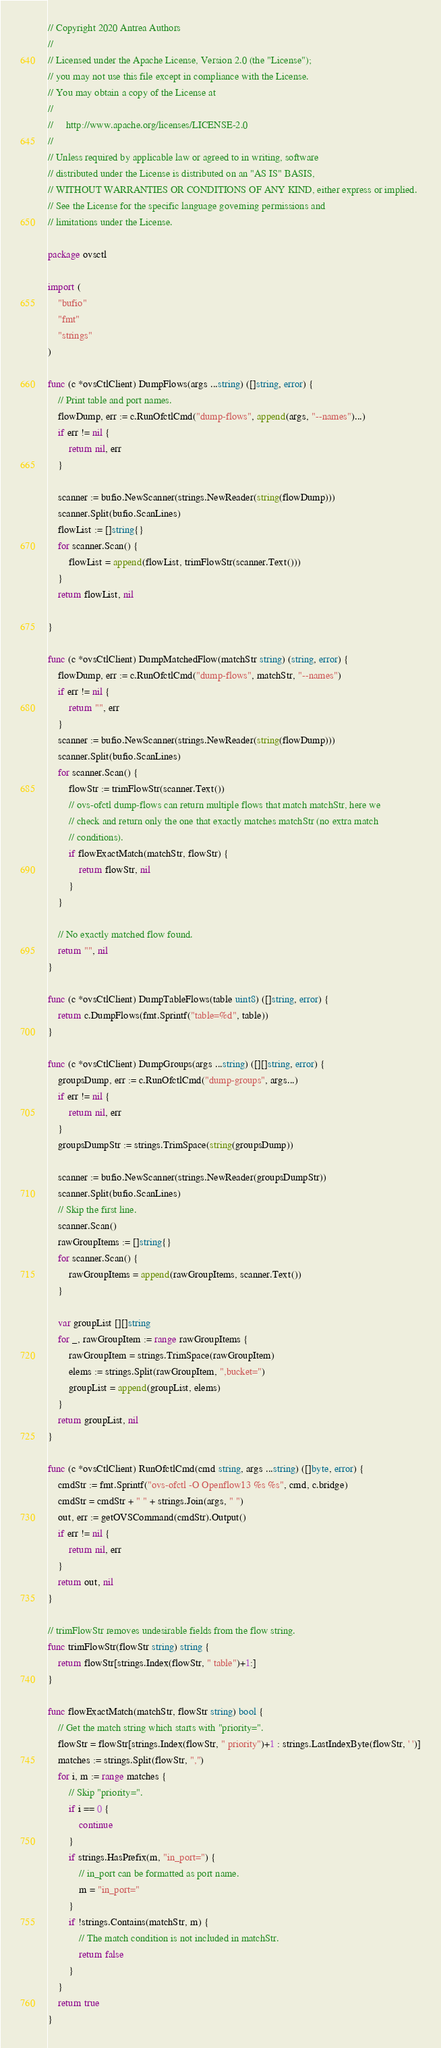<code> <loc_0><loc_0><loc_500><loc_500><_Go_>// Copyright 2020 Antrea Authors
//
// Licensed under the Apache License, Version 2.0 (the "License");
// you may not use this file except in compliance with the License.
// You may obtain a copy of the License at
//
//     http://www.apache.org/licenses/LICENSE-2.0
//
// Unless required by applicable law or agreed to in writing, software
// distributed under the License is distributed on an "AS IS" BASIS,
// WITHOUT WARRANTIES OR CONDITIONS OF ANY KIND, either express or implied.
// See the License for the specific language governing permissions and
// limitations under the License.

package ovsctl

import (
	"bufio"
	"fmt"
	"strings"
)

func (c *ovsCtlClient) DumpFlows(args ...string) ([]string, error) {
	// Print table and port names.
	flowDump, err := c.RunOfctlCmd("dump-flows", append(args, "--names")...)
	if err != nil {
		return nil, err
	}

	scanner := bufio.NewScanner(strings.NewReader(string(flowDump)))
	scanner.Split(bufio.ScanLines)
	flowList := []string{}
	for scanner.Scan() {
		flowList = append(flowList, trimFlowStr(scanner.Text()))
	}
	return flowList, nil

}

func (c *ovsCtlClient) DumpMatchedFlow(matchStr string) (string, error) {
	flowDump, err := c.RunOfctlCmd("dump-flows", matchStr, "--names")
	if err != nil {
		return "", err
	}
	scanner := bufio.NewScanner(strings.NewReader(string(flowDump)))
	scanner.Split(bufio.ScanLines)
	for scanner.Scan() {
		flowStr := trimFlowStr(scanner.Text())
		// ovs-ofctl dump-flows can return multiple flows that match matchStr, here we
		// check and return only the one that exactly matches matchStr (no extra match
		// conditions).
		if flowExactMatch(matchStr, flowStr) {
			return flowStr, nil
		}
	}

	// No exactly matched flow found.
	return "", nil
}

func (c *ovsCtlClient) DumpTableFlows(table uint8) ([]string, error) {
	return c.DumpFlows(fmt.Sprintf("table=%d", table))
}

func (c *ovsCtlClient) DumpGroups(args ...string) ([][]string, error) {
	groupsDump, err := c.RunOfctlCmd("dump-groups", args...)
	if err != nil {
		return nil, err
	}
	groupsDumpStr := strings.TrimSpace(string(groupsDump))

	scanner := bufio.NewScanner(strings.NewReader(groupsDumpStr))
	scanner.Split(bufio.ScanLines)
	// Skip the first line.
	scanner.Scan()
	rawGroupItems := []string{}
	for scanner.Scan() {
		rawGroupItems = append(rawGroupItems, scanner.Text())
	}

	var groupList [][]string
	for _, rawGroupItem := range rawGroupItems {
		rawGroupItem = strings.TrimSpace(rawGroupItem)
		elems := strings.Split(rawGroupItem, ",bucket=")
		groupList = append(groupList, elems)
	}
	return groupList, nil
}

func (c *ovsCtlClient) RunOfctlCmd(cmd string, args ...string) ([]byte, error) {
	cmdStr := fmt.Sprintf("ovs-ofctl -O Openflow13 %s %s", cmd, c.bridge)
	cmdStr = cmdStr + " " + strings.Join(args, " ")
	out, err := getOVSCommand(cmdStr).Output()
	if err != nil {
		return nil, err
	}
	return out, nil
}

// trimFlowStr removes undesirable fields from the flow string.
func trimFlowStr(flowStr string) string {
	return flowStr[strings.Index(flowStr, " table")+1:]
}

func flowExactMatch(matchStr, flowStr string) bool {
	// Get the match string which starts with "priority=".
	flowStr = flowStr[strings.Index(flowStr, " priority")+1 : strings.LastIndexByte(flowStr, ' ')]
	matches := strings.Split(flowStr, ",")
	for i, m := range matches {
		// Skip "priority=".
		if i == 0 {
			continue
		}
		if strings.HasPrefix(m, "in_port=") {
			// in_port can be formatted as port name.
			m = "in_port="
		}
		if !strings.Contains(matchStr, m) {
			// The match condition is not included in matchStr.
			return false
		}
	}
	return true
}
</code> 